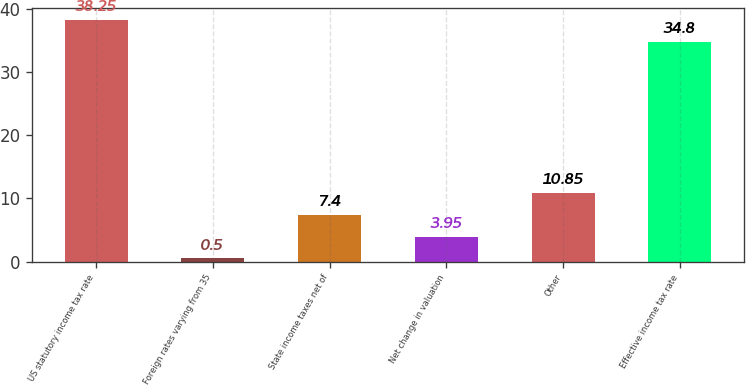Convert chart. <chart><loc_0><loc_0><loc_500><loc_500><bar_chart><fcel>US statutory income tax rate<fcel>Foreign rates varying from 35<fcel>State income taxes net of<fcel>Net change in valuation<fcel>Other<fcel>Effective income tax rate<nl><fcel>38.25<fcel>0.5<fcel>7.4<fcel>3.95<fcel>10.85<fcel>34.8<nl></chart> 